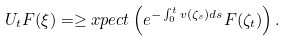<formula> <loc_0><loc_0><loc_500><loc_500>U _ { t } F ( \xi ) = \geq x p e c t \left ( e ^ { - \int _ { 0 } ^ { t } v ( \zeta _ { s } ) d s } F ( \zeta _ { t } ) \right ) .</formula> 